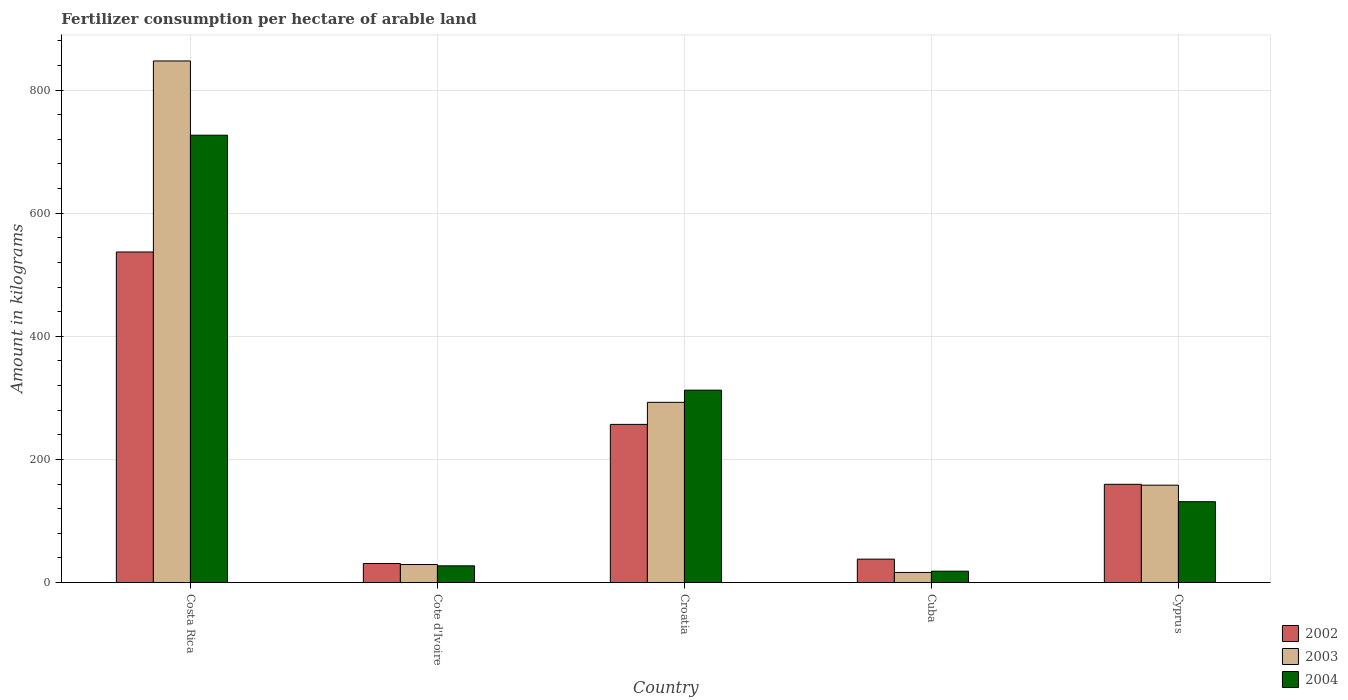How many groups of bars are there?
Your answer should be very brief. 5. How many bars are there on the 1st tick from the left?
Provide a succinct answer. 3. How many bars are there on the 3rd tick from the right?
Offer a very short reply. 3. What is the label of the 3rd group of bars from the left?
Provide a short and direct response. Croatia. What is the amount of fertilizer consumption in 2003 in Cuba?
Your answer should be compact. 16.5. Across all countries, what is the maximum amount of fertilizer consumption in 2004?
Make the answer very short. 726.7. Across all countries, what is the minimum amount of fertilizer consumption in 2002?
Your response must be concise. 31.02. In which country was the amount of fertilizer consumption in 2003 maximum?
Keep it short and to the point. Costa Rica. In which country was the amount of fertilizer consumption in 2002 minimum?
Your answer should be very brief. Cote d'Ivoire. What is the total amount of fertilizer consumption in 2002 in the graph?
Ensure brevity in your answer.  1022.77. What is the difference between the amount of fertilizer consumption in 2003 in Croatia and that in Cyprus?
Provide a short and direct response. 134.57. What is the difference between the amount of fertilizer consumption in 2003 in Costa Rica and the amount of fertilizer consumption in 2002 in Croatia?
Offer a terse response. 590.3. What is the average amount of fertilizer consumption in 2004 per country?
Your answer should be very brief. 243.29. What is the difference between the amount of fertilizer consumption of/in 2004 and amount of fertilizer consumption of/in 2002 in Cyprus?
Provide a short and direct response. -28.24. What is the ratio of the amount of fertilizer consumption in 2004 in Cote d'Ivoire to that in Croatia?
Your answer should be compact. 0.09. Is the difference between the amount of fertilizer consumption in 2004 in Cuba and Cyprus greater than the difference between the amount of fertilizer consumption in 2002 in Cuba and Cyprus?
Offer a very short reply. Yes. What is the difference between the highest and the second highest amount of fertilizer consumption in 2002?
Your answer should be very brief. -280.02. What is the difference between the highest and the lowest amount of fertilizer consumption in 2004?
Keep it short and to the point. 708.17. Is the sum of the amount of fertilizer consumption in 2002 in Cote d'Ivoire and Croatia greater than the maximum amount of fertilizer consumption in 2004 across all countries?
Provide a short and direct response. No. What does the 2nd bar from the left in Cuba represents?
Offer a terse response. 2003. What does the 3rd bar from the right in Cuba represents?
Make the answer very short. 2002. Is it the case that in every country, the sum of the amount of fertilizer consumption in 2003 and amount of fertilizer consumption in 2002 is greater than the amount of fertilizer consumption in 2004?
Give a very brief answer. Yes. How many countries are there in the graph?
Your response must be concise. 5. What is the difference between two consecutive major ticks on the Y-axis?
Your answer should be very brief. 200. Does the graph contain any zero values?
Keep it short and to the point. No. Does the graph contain grids?
Make the answer very short. Yes. Where does the legend appear in the graph?
Offer a terse response. Bottom right. How many legend labels are there?
Give a very brief answer. 3. What is the title of the graph?
Ensure brevity in your answer.  Fertilizer consumption per hectare of arable land. What is the label or title of the Y-axis?
Your answer should be compact. Amount in kilograms. What is the Amount in kilograms in 2002 in Costa Rica?
Provide a succinct answer. 537.01. What is the Amount in kilograms in 2003 in Costa Rica?
Your response must be concise. 847.29. What is the Amount in kilograms of 2004 in Costa Rica?
Provide a short and direct response. 726.7. What is the Amount in kilograms of 2002 in Cote d'Ivoire?
Ensure brevity in your answer.  31.02. What is the Amount in kilograms in 2003 in Cote d'Ivoire?
Keep it short and to the point. 29.35. What is the Amount in kilograms in 2004 in Cote d'Ivoire?
Offer a terse response. 27.22. What is the Amount in kilograms in 2002 in Croatia?
Provide a succinct answer. 256.99. What is the Amount in kilograms in 2003 in Croatia?
Ensure brevity in your answer.  292.8. What is the Amount in kilograms of 2004 in Croatia?
Offer a terse response. 312.58. What is the Amount in kilograms of 2002 in Cuba?
Keep it short and to the point. 38.1. What is the Amount in kilograms in 2003 in Cuba?
Your answer should be compact. 16.5. What is the Amount in kilograms in 2004 in Cuba?
Make the answer very short. 18.53. What is the Amount in kilograms of 2002 in Cyprus?
Keep it short and to the point. 159.65. What is the Amount in kilograms of 2003 in Cyprus?
Provide a succinct answer. 158.23. What is the Amount in kilograms in 2004 in Cyprus?
Provide a succinct answer. 131.41. Across all countries, what is the maximum Amount in kilograms in 2002?
Offer a very short reply. 537.01. Across all countries, what is the maximum Amount in kilograms of 2003?
Ensure brevity in your answer.  847.29. Across all countries, what is the maximum Amount in kilograms in 2004?
Provide a succinct answer. 726.7. Across all countries, what is the minimum Amount in kilograms in 2002?
Provide a short and direct response. 31.02. Across all countries, what is the minimum Amount in kilograms of 2003?
Offer a terse response. 16.5. Across all countries, what is the minimum Amount in kilograms in 2004?
Ensure brevity in your answer.  18.53. What is the total Amount in kilograms in 2002 in the graph?
Your answer should be very brief. 1022.77. What is the total Amount in kilograms of 2003 in the graph?
Ensure brevity in your answer.  1344.17. What is the total Amount in kilograms of 2004 in the graph?
Your answer should be compact. 1216.44. What is the difference between the Amount in kilograms of 2002 in Costa Rica and that in Cote d'Ivoire?
Ensure brevity in your answer.  505.99. What is the difference between the Amount in kilograms of 2003 in Costa Rica and that in Cote d'Ivoire?
Your answer should be compact. 817.95. What is the difference between the Amount in kilograms in 2004 in Costa Rica and that in Cote d'Ivoire?
Keep it short and to the point. 699.48. What is the difference between the Amount in kilograms in 2002 in Costa Rica and that in Croatia?
Provide a succinct answer. 280.02. What is the difference between the Amount in kilograms of 2003 in Costa Rica and that in Croatia?
Your response must be concise. 554.49. What is the difference between the Amount in kilograms of 2004 in Costa Rica and that in Croatia?
Keep it short and to the point. 414.11. What is the difference between the Amount in kilograms of 2002 in Costa Rica and that in Cuba?
Offer a very short reply. 498.91. What is the difference between the Amount in kilograms of 2003 in Costa Rica and that in Cuba?
Give a very brief answer. 830.79. What is the difference between the Amount in kilograms of 2004 in Costa Rica and that in Cuba?
Provide a succinct answer. 708.16. What is the difference between the Amount in kilograms of 2002 in Costa Rica and that in Cyprus?
Ensure brevity in your answer.  377.36. What is the difference between the Amount in kilograms of 2003 in Costa Rica and that in Cyprus?
Keep it short and to the point. 689.06. What is the difference between the Amount in kilograms in 2004 in Costa Rica and that in Cyprus?
Make the answer very short. 595.29. What is the difference between the Amount in kilograms in 2002 in Cote d'Ivoire and that in Croatia?
Make the answer very short. -225.97. What is the difference between the Amount in kilograms of 2003 in Cote d'Ivoire and that in Croatia?
Give a very brief answer. -263.46. What is the difference between the Amount in kilograms of 2004 in Cote d'Ivoire and that in Croatia?
Give a very brief answer. -285.37. What is the difference between the Amount in kilograms in 2002 in Cote d'Ivoire and that in Cuba?
Provide a short and direct response. -7.09. What is the difference between the Amount in kilograms in 2003 in Cote d'Ivoire and that in Cuba?
Make the answer very short. 12.84. What is the difference between the Amount in kilograms of 2004 in Cote d'Ivoire and that in Cuba?
Your answer should be very brief. 8.69. What is the difference between the Amount in kilograms of 2002 in Cote d'Ivoire and that in Cyprus?
Make the answer very short. -128.63. What is the difference between the Amount in kilograms in 2003 in Cote d'Ivoire and that in Cyprus?
Ensure brevity in your answer.  -128.89. What is the difference between the Amount in kilograms in 2004 in Cote d'Ivoire and that in Cyprus?
Give a very brief answer. -104.19. What is the difference between the Amount in kilograms of 2002 in Croatia and that in Cuba?
Keep it short and to the point. 218.88. What is the difference between the Amount in kilograms in 2003 in Croatia and that in Cuba?
Give a very brief answer. 276.3. What is the difference between the Amount in kilograms in 2004 in Croatia and that in Cuba?
Ensure brevity in your answer.  294.05. What is the difference between the Amount in kilograms of 2002 in Croatia and that in Cyprus?
Your answer should be very brief. 97.34. What is the difference between the Amount in kilograms of 2003 in Croatia and that in Cyprus?
Provide a succinct answer. 134.57. What is the difference between the Amount in kilograms of 2004 in Croatia and that in Cyprus?
Offer a very short reply. 181.18. What is the difference between the Amount in kilograms in 2002 in Cuba and that in Cyprus?
Your answer should be very brief. -121.55. What is the difference between the Amount in kilograms of 2003 in Cuba and that in Cyprus?
Give a very brief answer. -141.73. What is the difference between the Amount in kilograms of 2004 in Cuba and that in Cyprus?
Provide a short and direct response. -112.88. What is the difference between the Amount in kilograms of 2002 in Costa Rica and the Amount in kilograms of 2003 in Cote d'Ivoire?
Offer a very short reply. 507.66. What is the difference between the Amount in kilograms in 2002 in Costa Rica and the Amount in kilograms in 2004 in Cote d'Ivoire?
Provide a short and direct response. 509.79. What is the difference between the Amount in kilograms in 2003 in Costa Rica and the Amount in kilograms in 2004 in Cote d'Ivoire?
Your answer should be compact. 820.07. What is the difference between the Amount in kilograms of 2002 in Costa Rica and the Amount in kilograms of 2003 in Croatia?
Give a very brief answer. 244.21. What is the difference between the Amount in kilograms of 2002 in Costa Rica and the Amount in kilograms of 2004 in Croatia?
Offer a terse response. 224.43. What is the difference between the Amount in kilograms in 2003 in Costa Rica and the Amount in kilograms in 2004 in Croatia?
Give a very brief answer. 534.71. What is the difference between the Amount in kilograms in 2002 in Costa Rica and the Amount in kilograms in 2003 in Cuba?
Keep it short and to the point. 520.51. What is the difference between the Amount in kilograms in 2002 in Costa Rica and the Amount in kilograms in 2004 in Cuba?
Provide a short and direct response. 518.48. What is the difference between the Amount in kilograms in 2003 in Costa Rica and the Amount in kilograms in 2004 in Cuba?
Provide a short and direct response. 828.76. What is the difference between the Amount in kilograms in 2002 in Costa Rica and the Amount in kilograms in 2003 in Cyprus?
Ensure brevity in your answer.  378.78. What is the difference between the Amount in kilograms in 2002 in Costa Rica and the Amount in kilograms in 2004 in Cyprus?
Your answer should be very brief. 405.6. What is the difference between the Amount in kilograms in 2003 in Costa Rica and the Amount in kilograms in 2004 in Cyprus?
Your response must be concise. 715.88. What is the difference between the Amount in kilograms of 2002 in Cote d'Ivoire and the Amount in kilograms of 2003 in Croatia?
Give a very brief answer. -261.78. What is the difference between the Amount in kilograms of 2002 in Cote d'Ivoire and the Amount in kilograms of 2004 in Croatia?
Offer a very short reply. -281.57. What is the difference between the Amount in kilograms of 2003 in Cote d'Ivoire and the Amount in kilograms of 2004 in Croatia?
Provide a succinct answer. -283.24. What is the difference between the Amount in kilograms in 2002 in Cote d'Ivoire and the Amount in kilograms in 2003 in Cuba?
Offer a very short reply. 14.52. What is the difference between the Amount in kilograms in 2002 in Cote d'Ivoire and the Amount in kilograms in 2004 in Cuba?
Provide a short and direct response. 12.49. What is the difference between the Amount in kilograms of 2003 in Cote d'Ivoire and the Amount in kilograms of 2004 in Cuba?
Your answer should be compact. 10.82. What is the difference between the Amount in kilograms of 2002 in Cote d'Ivoire and the Amount in kilograms of 2003 in Cyprus?
Keep it short and to the point. -127.21. What is the difference between the Amount in kilograms of 2002 in Cote d'Ivoire and the Amount in kilograms of 2004 in Cyprus?
Your answer should be very brief. -100.39. What is the difference between the Amount in kilograms of 2003 in Cote d'Ivoire and the Amount in kilograms of 2004 in Cyprus?
Offer a very short reply. -102.06. What is the difference between the Amount in kilograms in 2002 in Croatia and the Amount in kilograms in 2003 in Cuba?
Your response must be concise. 240.49. What is the difference between the Amount in kilograms of 2002 in Croatia and the Amount in kilograms of 2004 in Cuba?
Provide a succinct answer. 238.46. What is the difference between the Amount in kilograms in 2003 in Croatia and the Amount in kilograms in 2004 in Cuba?
Offer a very short reply. 274.27. What is the difference between the Amount in kilograms in 2002 in Croatia and the Amount in kilograms in 2003 in Cyprus?
Provide a succinct answer. 98.76. What is the difference between the Amount in kilograms of 2002 in Croatia and the Amount in kilograms of 2004 in Cyprus?
Give a very brief answer. 125.58. What is the difference between the Amount in kilograms of 2003 in Croatia and the Amount in kilograms of 2004 in Cyprus?
Ensure brevity in your answer.  161.4. What is the difference between the Amount in kilograms in 2002 in Cuba and the Amount in kilograms in 2003 in Cyprus?
Keep it short and to the point. -120.13. What is the difference between the Amount in kilograms of 2002 in Cuba and the Amount in kilograms of 2004 in Cyprus?
Make the answer very short. -93.3. What is the difference between the Amount in kilograms in 2003 in Cuba and the Amount in kilograms in 2004 in Cyprus?
Offer a terse response. -114.9. What is the average Amount in kilograms in 2002 per country?
Offer a very short reply. 204.55. What is the average Amount in kilograms in 2003 per country?
Ensure brevity in your answer.  268.83. What is the average Amount in kilograms of 2004 per country?
Your answer should be compact. 243.29. What is the difference between the Amount in kilograms of 2002 and Amount in kilograms of 2003 in Costa Rica?
Make the answer very short. -310.28. What is the difference between the Amount in kilograms of 2002 and Amount in kilograms of 2004 in Costa Rica?
Make the answer very short. -189.69. What is the difference between the Amount in kilograms in 2003 and Amount in kilograms in 2004 in Costa Rica?
Your answer should be very brief. 120.6. What is the difference between the Amount in kilograms in 2002 and Amount in kilograms in 2003 in Cote d'Ivoire?
Offer a terse response. 1.67. What is the difference between the Amount in kilograms in 2003 and Amount in kilograms in 2004 in Cote d'Ivoire?
Make the answer very short. 2.13. What is the difference between the Amount in kilograms of 2002 and Amount in kilograms of 2003 in Croatia?
Your response must be concise. -35.81. What is the difference between the Amount in kilograms of 2002 and Amount in kilograms of 2004 in Croatia?
Your answer should be compact. -55.6. What is the difference between the Amount in kilograms in 2003 and Amount in kilograms in 2004 in Croatia?
Keep it short and to the point. -19.78. What is the difference between the Amount in kilograms in 2002 and Amount in kilograms in 2003 in Cuba?
Give a very brief answer. 21.6. What is the difference between the Amount in kilograms in 2002 and Amount in kilograms in 2004 in Cuba?
Provide a succinct answer. 19.57. What is the difference between the Amount in kilograms in 2003 and Amount in kilograms in 2004 in Cuba?
Keep it short and to the point. -2.03. What is the difference between the Amount in kilograms of 2002 and Amount in kilograms of 2003 in Cyprus?
Your answer should be compact. 1.42. What is the difference between the Amount in kilograms in 2002 and Amount in kilograms in 2004 in Cyprus?
Your answer should be compact. 28.24. What is the difference between the Amount in kilograms of 2003 and Amount in kilograms of 2004 in Cyprus?
Provide a short and direct response. 26.83. What is the ratio of the Amount in kilograms in 2002 in Costa Rica to that in Cote d'Ivoire?
Keep it short and to the point. 17.31. What is the ratio of the Amount in kilograms of 2003 in Costa Rica to that in Cote d'Ivoire?
Provide a short and direct response. 28.87. What is the ratio of the Amount in kilograms of 2004 in Costa Rica to that in Cote d'Ivoire?
Make the answer very short. 26.7. What is the ratio of the Amount in kilograms of 2002 in Costa Rica to that in Croatia?
Make the answer very short. 2.09. What is the ratio of the Amount in kilograms in 2003 in Costa Rica to that in Croatia?
Your answer should be compact. 2.89. What is the ratio of the Amount in kilograms of 2004 in Costa Rica to that in Croatia?
Your answer should be compact. 2.32. What is the ratio of the Amount in kilograms of 2002 in Costa Rica to that in Cuba?
Offer a terse response. 14.09. What is the ratio of the Amount in kilograms of 2003 in Costa Rica to that in Cuba?
Your answer should be compact. 51.34. What is the ratio of the Amount in kilograms of 2004 in Costa Rica to that in Cuba?
Provide a short and direct response. 39.22. What is the ratio of the Amount in kilograms of 2002 in Costa Rica to that in Cyprus?
Offer a very short reply. 3.36. What is the ratio of the Amount in kilograms in 2003 in Costa Rica to that in Cyprus?
Your response must be concise. 5.35. What is the ratio of the Amount in kilograms in 2004 in Costa Rica to that in Cyprus?
Ensure brevity in your answer.  5.53. What is the ratio of the Amount in kilograms in 2002 in Cote d'Ivoire to that in Croatia?
Your answer should be very brief. 0.12. What is the ratio of the Amount in kilograms in 2003 in Cote d'Ivoire to that in Croatia?
Your answer should be compact. 0.1. What is the ratio of the Amount in kilograms in 2004 in Cote d'Ivoire to that in Croatia?
Ensure brevity in your answer.  0.09. What is the ratio of the Amount in kilograms of 2002 in Cote d'Ivoire to that in Cuba?
Ensure brevity in your answer.  0.81. What is the ratio of the Amount in kilograms of 2003 in Cote d'Ivoire to that in Cuba?
Your response must be concise. 1.78. What is the ratio of the Amount in kilograms in 2004 in Cote d'Ivoire to that in Cuba?
Give a very brief answer. 1.47. What is the ratio of the Amount in kilograms of 2002 in Cote d'Ivoire to that in Cyprus?
Offer a terse response. 0.19. What is the ratio of the Amount in kilograms of 2003 in Cote d'Ivoire to that in Cyprus?
Offer a terse response. 0.19. What is the ratio of the Amount in kilograms of 2004 in Cote d'Ivoire to that in Cyprus?
Give a very brief answer. 0.21. What is the ratio of the Amount in kilograms in 2002 in Croatia to that in Cuba?
Ensure brevity in your answer.  6.74. What is the ratio of the Amount in kilograms in 2003 in Croatia to that in Cuba?
Your response must be concise. 17.74. What is the ratio of the Amount in kilograms in 2004 in Croatia to that in Cuba?
Provide a short and direct response. 16.87. What is the ratio of the Amount in kilograms in 2002 in Croatia to that in Cyprus?
Your answer should be very brief. 1.61. What is the ratio of the Amount in kilograms of 2003 in Croatia to that in Cyprus?
Keep it short and to the point. 1.85. What is the ratio of the Amount in kilograms in 2004 in Croatia to that in Cyprus?
Offer a very short reply. 2.38. What is the ratio of the Amount in kilograms in 2002 in Cuba to that in Cyprus?
Make the answer very short. 0.24. What is the ratio of the Amount in kilograms of 2003 in Cuba to that in Cyprus?
Offer a very short reply. 0.1. What is the ratio of the Amount in kilograms of 2004 in Cuba to that in Cyprus?
Ensure brevity in your answer.  0.14. What is the difference between the highest and the second highest Amount in kilograms of 2002?
Give a very brief answer. 280.02. What is the difference between the highest and the second highest Amount in kilograms in 2003?
Give a very brief answer. 554.49. What is the difference between the highest and the second highest Amount in kilograms in 2004?
Provide a succinct answer. 414.11. What is the difference between the highest and the lowest Amount in kilograms of 2002?
Make the answer very short. 505.99. What is the difference between the highest and the lowest Amount in kilograms of 2003?
Ensure brevity in your answer.  830.79. What is the difference between the highest and the lowest Amount in kilograms in 2004?
Your answer should be very brief. 708.16. 